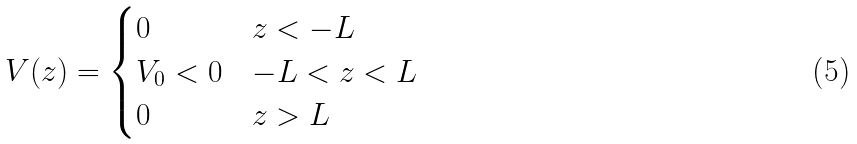<formula> <loc_0><loc_0><loc_500><loc_500>V ( z ) = \begin{cases} 0 & z < - L \\ V _ { 0 } < 0 & - L < z < L \\ 0 & z > L \end{cases}</formula> 